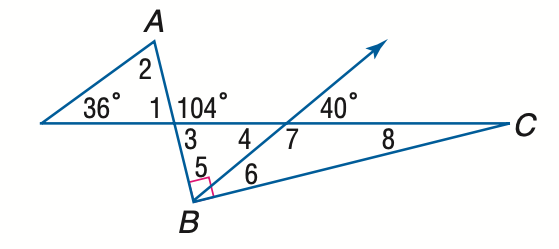Answer the mathemtical geometry problem and directly provide the correct option letter.
Question: Find the measure of \angle 6 if A B \perp B C.
Choices: A: 21 B: 26 C: 31 D: 36 B 